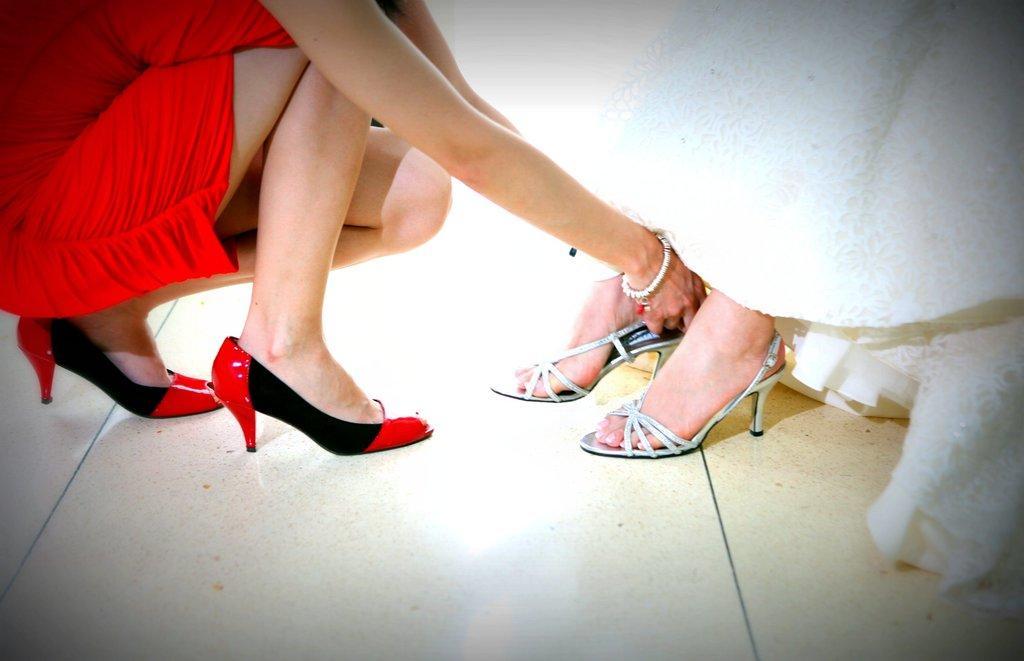Please provide a concise description of this image. This picture describes about few people, on the left side of the image we can see a woman, she wore a red color dress, and she is holding sandals. 